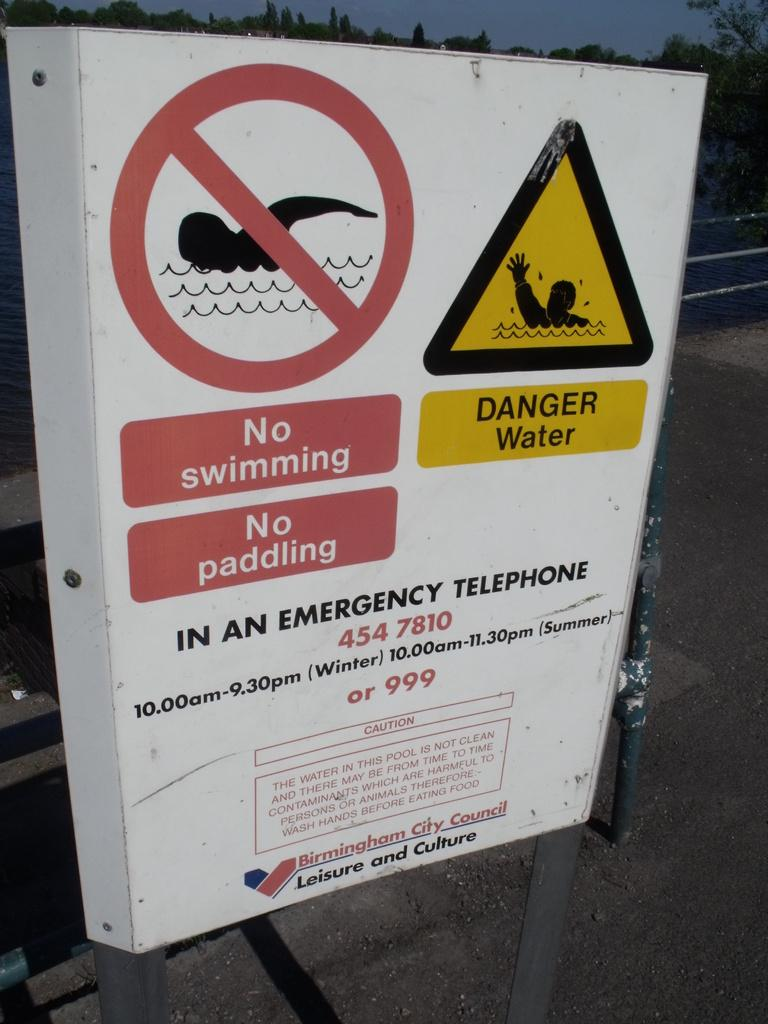<image>
Present a compact description of the photo's key features. A no swimming and no paddling sign by the water. 